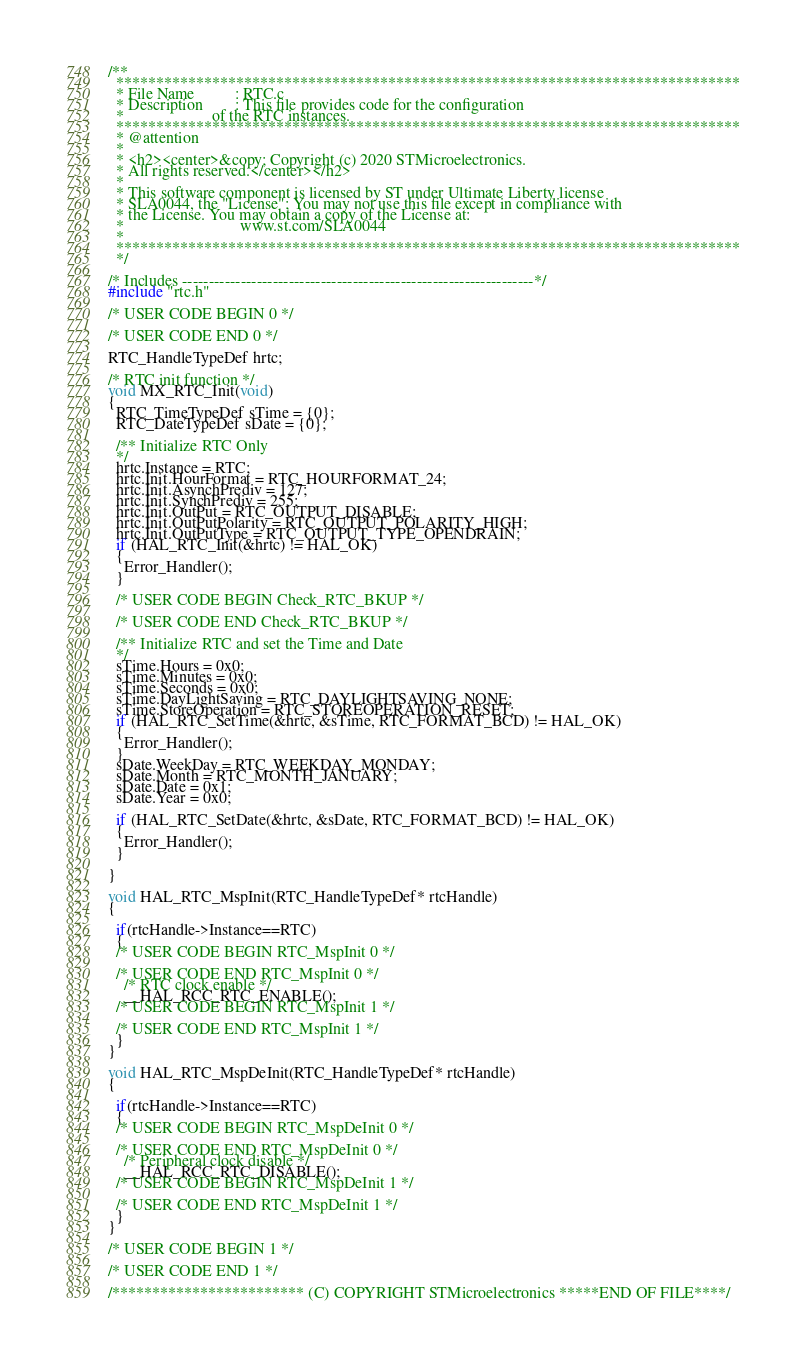Convert code to text. <code><loc_0><loc_0><loc_500><loc_500><_C_>/**
  ******************************************************************************
  * File Name          : RTC.c
  * Description        : This file provides code for the configuration
  *                      of the RTC instances.
  ******************************************************************************
  * @attention
  *
  * <h2><center>&copy; Copyright (c) 2020 STMicroelectronics.
  * All rights reserved.</center></h2>
  *
  * This software component is licensed by ST under Ultimate Liberty license
  * SLA0044, the "License"; You may not use this file except in compliance with
  * the License. You may obtain a copy of the License at:
  *                             www.st.com/SLA0044
  *
  ******************************************************************************
  */

/* Includes ------------------------------------------------------------------*/
#include "rtc.h"

/* USER CODE BEGIN 0 */

/* USER CODE END 0 */

RTC_HandleTypeDef hrtc;

/* RTC init function */
void MX_RTC_Init(void)
{
  RTC_TimeTypeDef sTime = {0};
  RTC_DateTypeDef sDate = {0};

  /** Initialize RTC Only 
  */
  hrtc.Instance = RTC;
  hrtc.Init.HourFormat = RTC_HOURFORMAT_24;
  hrtc.Init.AsynchPrediv = 127;
  hrtc.Init.SynchPrediv = 255;
  hrtc.Init.OutPut = RTC_OUTPUT_DISABLE;
  hrtc.Init.OutPutPolarity = RTC_OUTPUT_POLARITY_HIGH;
  hrtc.Init.OutPutType = RTC_OUTPUT_TYPE_OPENDRAIN;
  if (HAL_RTC_Init(&hrtc) != HAL_OK)
  {
    Error_Handler();
  }

  /* USER CODE BEGIN Check_RTC_BKUP */
    
  /* USER CODE END Check_RTC_BKUP */

  /** Initialize RTC and set the Time and Date 
  */
  sTime.Hours = 0x0;
  sTime.Minutes = 0x0;
  sTime.Seconds = 0x0;
  sTime.DayLightSaving = RTC_DAYLIGHTSAVING_NONE;
  sTime.StoreOperation = RTC_STOREOPERATION_RESET;
  if (HAL_RTC_SetTime(&hrtc, &sTime, RTC_FORMAT_BCD) != HAL_OK)
  {
    Error_Handler();
  }
  sDate.WeekDay = RTC_WEEKDAY_MONDAY;
  sDate.Month = RTC_MONTH_JANUARY;
  sDate.Date = 0x1;
  sDate.Year = 0x0;

  if (HAL_RTC_SetDate(&hrtc, &sDate, RTC_FORMAT_BCD) != HAL_OK)
  {
    Error_Handler();
  }

}

void HAL_RTC_MspInit(RTC_HandleTypeDef* rtcHandle)
{

  if(rtcHandle->Instance==RTC)
  {
  /* USER CODE BEGIN RTC_MspInit 0 */

  /* USER CODE END RTC_MspInit 0 */
    /* RTC clock enable */
    __HAL_RCC_RTC_ENABLE();
  /* USER CODE BEGIN RTC_MspInit 1 */

  /* USER CODE END RTC_MspInit 1 */
  }
}

void HAL_RTC_MspDeInit(RTC_HandleTypeDef* rtcHandle)
{

  if(rtcHandle->Instance==RTC)
  {
  /* USER CODE BEGIN RTC_MspDeInit 0 */

  /* USER CODE END RTC_MspDeInit 0 */
    /* Peripheral clock disable */
    __HAL_RCC_RTC_DISABLE();
  /* USER CODE BEGIN RTC_MspDeInit 1 */

  /* USER CODE END RTC_MspDeInit 1 */
  }
} 

/* USER CODE BEGIN 1 */

/* USER CODE END 1 */

/************************ (C) COPYRIGHT STMicroelectronics *****END OF FILE****/
</code> 